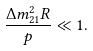Convert formula to latex. <formula><loc_0><loc_0><loc_500><loc_500>\frac { \Delta m _ { 2 1 } ^ { 2 } R } { p } \ll 1 .</formula> 